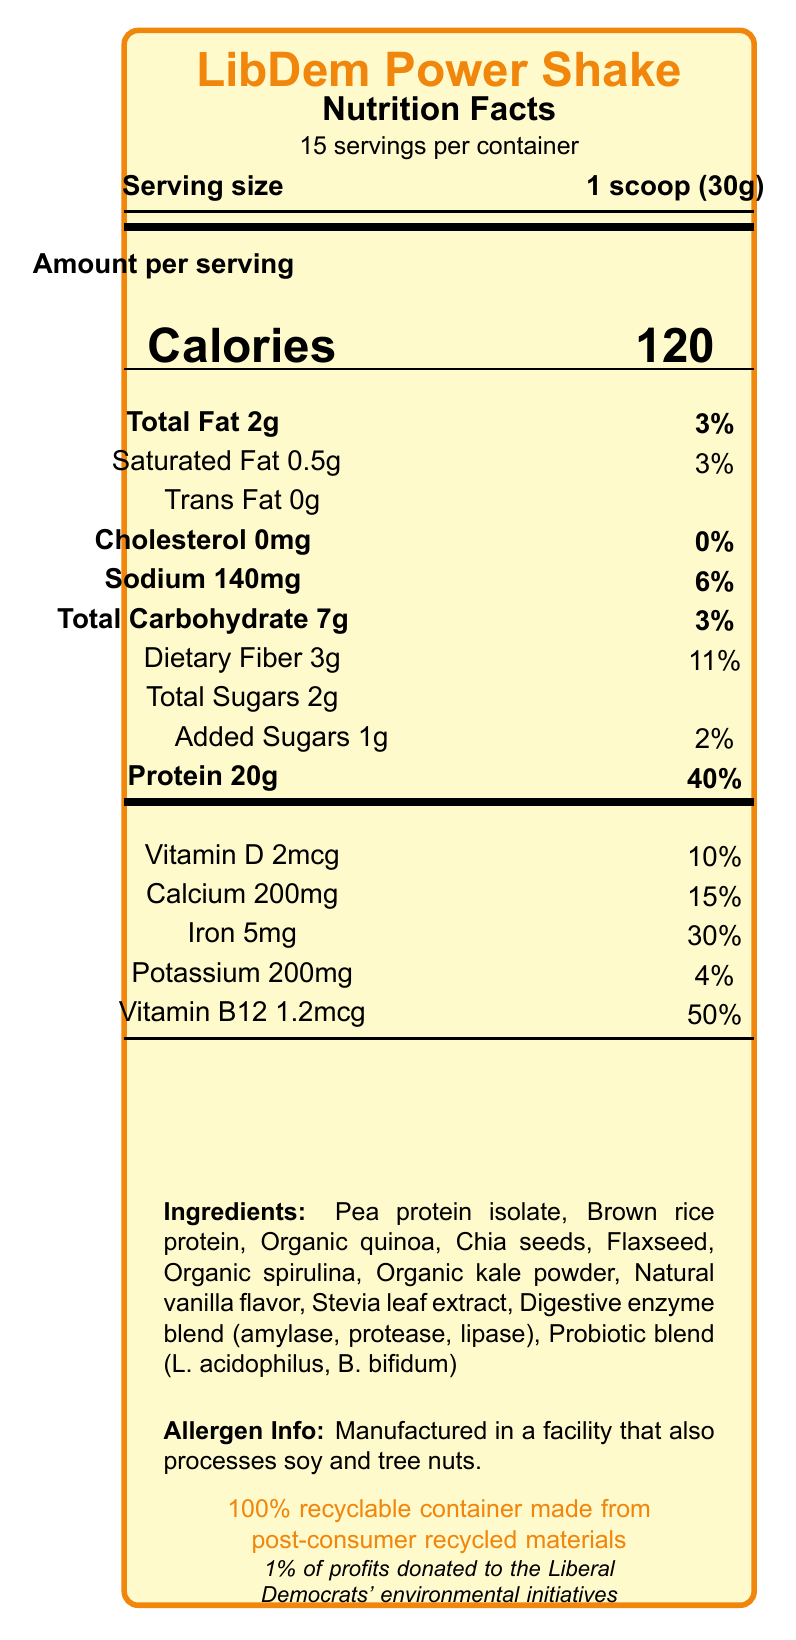what is the serving size of the LibDem Power Shake? The serving size is provided at the top of the document under "Serving size."
Answer: 1 scoop (30g) how many calories are there in one serving? The number of calories per serving is listed prominently in the center of the document next to the word "Calories."
Answer: 120 what is the total fat content per serving? The total fat content is labeled "Total Fat" and is shown to be 2g.
Answer: 2g what are the sources of protein in this shake? The ingredients list at the bottom includes "Pea protein isolate" and "Brown rice protein" among other ingredients.
Answer: Pea protein isolate, Brown rice protein how much protein does one serving contain? The protein content is highlighted under "Protein," showing the amount as 20g.
Answer: 20g what percentage of the daily value of Iron does one serving provide? The Iron content is listed as 30% of the daily value.
Answer: 30% which additive provides the fiber in this protein shake? Dietary fiber is commonly derived from seeds like chia seeds and flaxseed, both listed in the ingredients.
Answer: Chia seeds, Flaxseed is there any cholesterol in one serving of this shake? The cholesterol content is listed as "0mg," indicating there is no cholesterol per serving.
Answer: No what is the allergen information provided? This information is stated clearly at the bottom of the document under "Allergen Info."
Answer: Manufactured in a facility that also processes soy and tree nuts. which of the following vitamins has the highest percentage of daily value in a serving? A. Vitamin D B. Vitamin B12 C. Calcium D. Iron Vitamin B12 has the highest percentage of daily value at 50%.
Answer: B. Vitamin B12 how many servings are there per container? The document states there are 15 servings per container.
Answer: 15 what is the slogan of the LibDem Power Shake? The slogan is stated at the bottom of the document in a prominent manner.
Answer: Fuel your campaign with compassion and sustainability what additional environmental initiative does the product contribute to? This information is included at the bottom of the document and details the specific contribution.
Answer: 1% of profits donated to the Liberal Democrats' environmental initiatives is the packaging of the LibDem Power Shake eco-friendly? The document states that the packaging is a 100% recyclable container made from post-consumer recycled materials.
Answer: Yes summarize the main idea of the LibDem Power Shake document. This summary encapsulates the major aspects including nutritional content, ethical and eco-friendly production, and political alignment.
Answer: The LibDem Power Shake is a nutrition-conscious, eco-friendly vegetarian protein shake tailored for Liberal Democrat campaigners. It offers a balanced nutrition profile, ethical sourcing, and supports environmental initiatives with a portion of profits. is there any information on the amount of sugar added? The document mentions that there are 2g of total sugars and specifies that 1g is added sugar.
Answer: Yes, 1g added sugars per serving what is the daily value percentage of calcium in one serving? The document lists calcium as providing 15% of the daily value.
Answer: 15% explain the ethical sourcing claim made by the product. The document states that all ingredients are ethically sourced from fair-trade certified suppliers, indicating responsible sourcing practices.
Answer: All ingredients are ethically sourced from fair-trade certified suppliers. which digestive enzymes are included in the shake? A. Amylase B. Protease C. Lipase D. All of the above The ingredients list includes a Digestive enzyme blend containing amylase, protease, and lipase.
Answer: D. All of the above what specific blend of probiotics is in the shake? The probiotic blend detailed in the ingredients includes L. acidophilus and B. bifidum.
Answer: L. acidophilus, B. bifidum does the document provide specific information about sugar sources? The document lists "Total Sugars" and "Added Sugars" but does not specify their sources.
Answer: Not enough information 